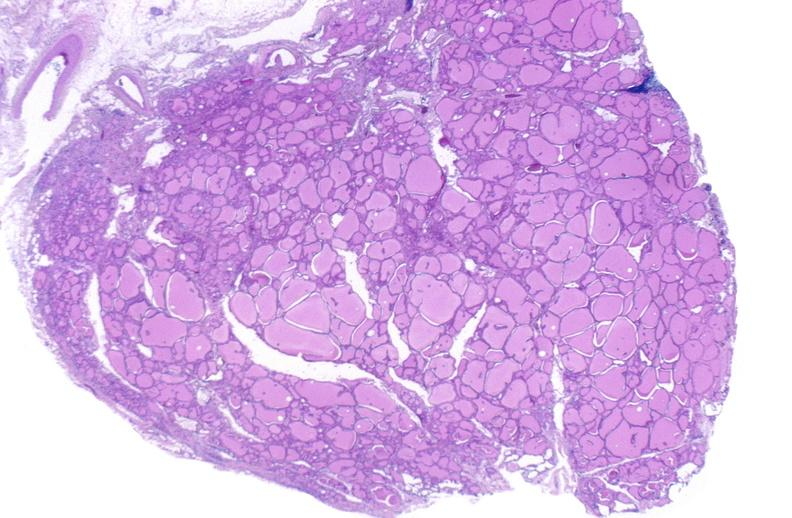where is this part in the figure?
Answer the question using a single word or phrase. Endocrine system 